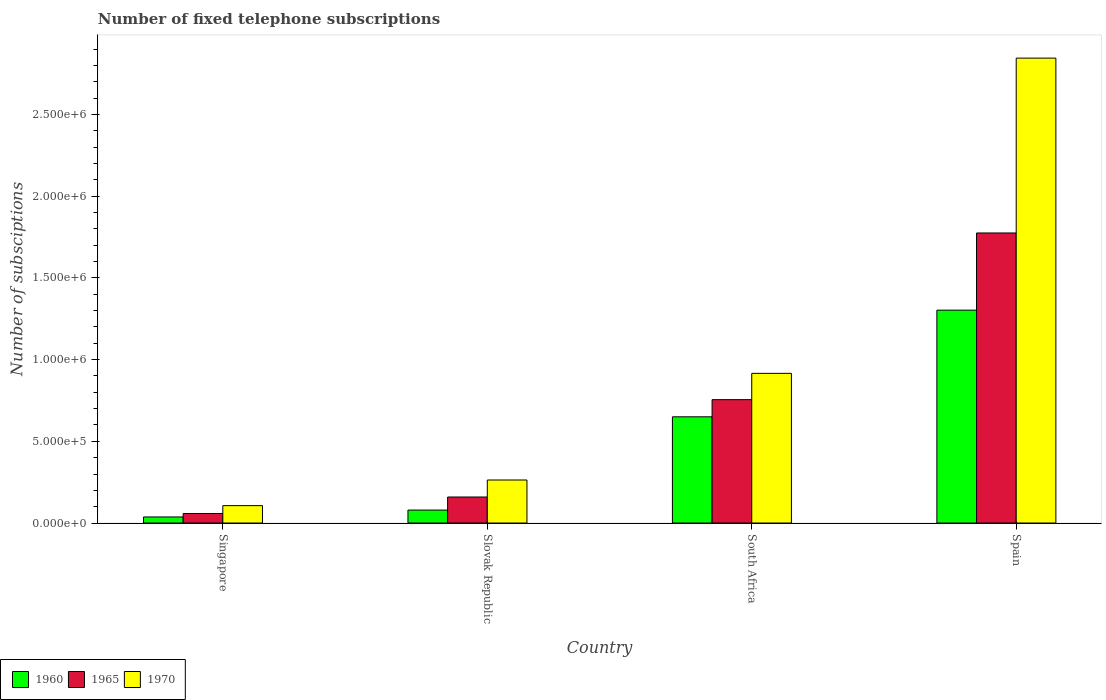How many bars are there on the 2nd tick from the left?
Provide a succinct answer. 3. What is the label of the 2nd group of bars from the left?
Offer a very short reply. Slovak Republic. In how many cases, is the number of bars for a given country not equal to the number of legend labels?
Keep it short and to the point. 0. What is the number of fixed telephone subscriptions in 1960 in Spain?
Your answer should be compact. 1.30e+06. Across all countries, what is the maximum number of fixed telephone subscriptions in 1970?
Give a very brief answer. 2.84e+06. Across all countries, what is the minimum number of fixed telephone subscriptions in 1960?
Ensure brevity in your answer.  3.71e+04. In which country was the number of fixed telephone subscriptions in 1970 maximum?
Offer a very short reply. Spain. In which country was the number of fixed telephone subscriptions in 1960 minimum?
Your answer should be compact. Singapore. What is the total number of fixed telephone subscriptions in 1960 in the graph?
Offer a very short reply. 2.07e+06. What is the difference between the number of fixed telephone subscriptions in 1960 in Singapore and that in Spain?
Your response must be concise. -1.27e+06. What is the difference between the number of fixed telephone subscriptions in 1960 in Singapore and the number of fixed telephone subscriptions in 1965 in Spain?
Keep it short and to the point. -1.74e+06. What is the average number of fixed telephone subscriptions in 1970 per country?
Offer a terse response. 1.03e+06. What is the difference between the number of fixed telephone subscriptions of/in 1965 and number of fixed telephone subscriptions of/in 1970 in South Africa?
Your answer should be compact. -1.61e+05. What is the ratio of the number of fixed telephone subscriptions in 1960 in Slovak Republic to that in Spain?
Make the answer very short. 0.06. Is the number of fixed telephone subscriptions in 1960 in Slovak Republic less than that in South Africa?
Ensure brevity in your answer.  Yes. Is the difference between the number of fixed telephone subscriptions in 1965 in Singapore and South Africa greater than the difference between the number of fixed telephone subscriptions in 1970 in Singapore and South Africa?
Your answer should be compact. Yes. What is the difference between the highest and the second highest number of fixed telephone subscriptions in 1965?
Your answer should be very brief. 1.02e+06. What is the difference between the highest and the lowest number of fixed telephone subscriptions in 1970?
Your answer should be compact. 2.74e+06. What does the 2nd bar from the left in South Africa represents?
Your answer should be very brief. 1965. What does the 2nd bar from the right in South Africa represents?
Ensure brevity in your answer.  1965. Is it the case that in every country, the sum of the number of fixed telephone subscriptions in 1970 and number of fixed telephone subscriptions in 1960 is greater than the number of fixed telephone subscriptions in 1965?
Provide a short and direct response. Yes. How many countries are there in the graph?
Offer a terse response. 4. What is the difference between two consecutive major ticks on the Y-axis?
Ensure brevity in your answer.  5.00e+05. Does the graph contain grids?
Keep it short and to the point. No. Where does the legend appear in the graph?
Keep it short and to the point. Bottom left. How many legend labels are there?
Provide a succinct answer. 3. What is the title of the graph?
Provide a succinct answer. Number of fixed telephone subscriptions. What is the label or title of the Y-axis?
Keep it short and to the point. Number of subsciptions. What is the Number of subsciptions of 1960 in Singapore?
Give a very brief answer. 3.71e+04. What is the Number of subsciptions in 1965 in Singapore?
Your answer should be compact. 5.84e+04. What is the Number of subsciptions in 1970 in Singapore?
Your answer should be very brief. 1.06e+05. What is the Number of subsciptions of 1960 in Slovak Republic?
Ensure brevity in your answer.  7.93e+04. What is the Number of subsciptions of 1965 in Slovak Republic?
Give a very brief answer. 1.59e+05. What is the Number of subsciptions in 1970 in Slovak Republic?
Your answer should be compact. 2.63e+05. What is the Number of subsciptions of 1960 in South Africa?
Provide a succinct answer. 6.50e+05. What is the Number of subsciptions of 1965 in South Africa?
Keep it short and to the point. 7.55e+05. What is the Number of subsciptions of 1970 in South Africa?
Provide a short and direct response. 9.16e+05. What is the Number of subsciptions in 1960 in Spain?
Give a very brief answer. 1.30e+06. What is the Number of subsciptions of 1965 in Spain?
Ensure brevity in your answer.  1.78e+06. What is the Number of subsciptions in 1970 in Spain?
Provide a succinct answer. 2.84e+06. Across all countries, what is the maximum Number of subsciptions of 1960?
Provide a short and direct response. 1.30e+06. Across all countries, what is the maximum Number of subsciptions of 1965?
Your answer should be compact. 1.78e+06. Across all countries, what is the maximum Number of subsciptions in 1970?
Keep it short and to the point. 2.84e+06. Across all countries, what is the minimum Number of subsciptions in 1960?
Offer a terse response. 3.71e+04. Across all countries, what is the minimum Number of subsciptions of 1965?
Give a very brief answer. 5.84e+04. Across all countries, what is the minimum Number of subsciptions in 1970?
Your answer should be very brief. 1.06e+05. What is the total Number of subsciptions of 1960 in the graph?
Make the answer very short. 2.07e+06. What is the total Number of subsciptions of 1965 in the graph?
Your answer should be compact. 2.75e+06. What is the total Number of subsciptions of 1970 in the graph?
Provide a succinct answer. 4.13e+06. What is the difference between the Number of subsciptions of 1960 in Singapore and that in Slovak Republic?
Provide a succinct answer. -4.22e+04. What is the difference between the Number of subsciptions of 1965 in Singapore and that in Slovak Republic?
Give a very brief answer. -1.01e+05. What is the difference between the Number of subsciptions of 1970 in Singapore and that in Slovak Republic?
Provide a succinct answer. -1.57e+05. What is the difference between the Number of subsciptions in 1960 in Singapore and that in South Africa?
Your answer should be compact. -6.13e+05. What is the difference between the Number of subsciptions in 1965 in Singapore and that in South Africa?
Give a very brief answer. -6.97e+05. What is the difference between the Number of subsciptions in 1970 in Singapore and that in South Africa?
Make the answer very short. -8.10e+05. What is the difference between the Number of subsciptions of 1960 in Singapore and that in Spain?
Your answer should be very brief. -1.27e+06. What is the difference between the Number of subsciptions of 1965 in Singapore and that in Spain?
Your answer should be very brief. -1.72e+06. What is the difference between the Number of subsciptions of 1970 in Singapore and that in Spain?
Provide a succinct answer. -2.74e+06. What is the difference between the Number of subsciptions of 1960 in Slovak Republic and that in South Africa?
Ensure brevity in your answer.  -5.71e+05. What is the difference between the Number of subsciptions in 1965 in Slovak Republic and that in South Africa?
Keep it short and to the point. -5.96e+05. What is the difference between the Number of subsciptions of 1970 in Slovak Republic and that in South Africa?
Provide a succinct answer. -6.53e+05. What is the difference between the Number of subsciptions of 1960 in Slovak Republic and that in Spain?
Offer a very short reply. -1.22e+06. What is the difference between the Number of subsciptions of 1965 in Slovak Republic and that in Spain?
Give a very brief answer. -1.62e+06. What is the difference between the Number of subsciptions of 1970 in Slovak Republic and that in Spain?
Provide a succinct answer. -2.58e+06. What is the difference between the Number of subsciptions in 1960 in South Africa and that in Spain?
Provide a succinct answer. -6.53e+05. What is the difference between the Number of subsciptions in 1965 in South Africa and that in Spain?
Keep it short and to the point. -1.02e+06. What is the difference between the Number of subsciptions in 1970 in South Africa and that in Spain?
Your answer should be compact. -1.93e+06. What is the difference between the Number of subsciptions of 1960 in Singapore and the Number of subsciptions of 1965 in Slovak Republic?
Your answer should be compact. -1.22e+05. What is the difference between the Number of subsciptions of 1960 in Singapore and the Number of subsciptions of 1970 in Slovak Republic?
Your answer should be very brief. -2.26e+05. What is the difference between the Number of subsciptions in 1965 in Singapore and the Number of subsciptions in 1970 in Slovak Republic?
Keep it short and to the point. -2.05e+05. What is the difference between the Number of subsciptions of 1960 in Singapore and the Number of subsciptions of 1965 in South Africa?
Offer a terse response. -7.18e+05. What is the difference between the Number of subsciptions of 1960 in Singapore and the Number of subsciptions of 1970 in South Africa?
Provide a short and direct response. -8.79e+05. What is the difference between the Number of subsciptions of 1965 in Singapore and the Number of subsciptions of 1970 in South Africa?
Offer a very short reply. -8.58e+05. What is the difference between the Number of subsciptions in 1960 in Singapore and the Number of subsciptions in 1965 in Spain?
Offer a terse response. -1.74e+06. What is the difference between the Number of subsciptions in 1960 in Singapore and the Number of subsciptions in 1970 in Spain?
Offer a terse response. -2.81e+06. What is the difference between the Number of subsciptions in 1965 in Singapore and the Number of subsciptions in 1970 in Spain?
Your answer should be very brief. -2.79e+06. What is the difference between the Number of subsciptions of 1960 in Slovak Republic and the Number of subsciptions of 1965 in South Africa?
Your answer should be compact. -6.76e+05. What is the difference between the Number of subsciptions of 1960 in Slovak Republic and the Number of subsciptions of 1970 in South Africa?
Provide a succinct answer. -8.37e+05. What is the difference between the Number of subsciptions in 1965 in Slovak Republic and the Number of subsciptions in 1970 in South Africa?
Ensure brevity in your answer.  -7.57e+05. What is the difference between the Number of subsciptions in 1960 in Slovak Republic and the Number of subsciptions in 1965 in Spain?
Your response must be concise. -1.70e+06. What is the difference between the Number of subsciptions of 1960 in Slovak Republic and the Number of subsciptions of 1970 in Spain?
Your response must be concise. -2.77e+06. What is the difference between the Number of subsciptions in 1965 in Slovak Republic and the Number of subsciptions in 1970 in Spain?
Your response must be concise. -2.69e+06. What is the difference between the Number of subsciptions of 1960 in South Africa and the Number of subsciptions of 1965 in Spain?
Keep it short and to the point. -1.12e+06. What is the difference between the Number of subsciptions of 1960 in South Africa and the Number of subsciptions of 1970 in Spain?
Your answer should be compact. -2.19e+06. What is the difference between the Number of subsciptions in 1965 in South Africa and the Number of subsciptions in 1970 in Spain?
Offer a very short reply. -2.09e+06. What is the average Number of subsciptions of 1960 per country?
Keep it short and to the point. 5.17e+05. What is the average Number of subsciptions of 1965 per country?
Offer a terse response. 6.87e+05. What is the average Number of subsciptions in 1970 per country?
Ensure brevity in your answer.  1.03e+06. What is the difference between the Number of subsciptions in 1960 and Number of subsciptions in 1965 in Singapore?
Your answer should be compact. -2.13e+04. What is the difference between the Number of subsciptions of 1960 and Number of subsciptions of 1970 in Singapore?
Provide a succinct answer. -6.93e+04. What is the difference between the Number of subsciptions in 1965 and Number of subsciptions in 1970 in Singapore?
Provide a short and direct response. -4.81e+04. What is the difference between the Number of subsciptions in 1960 and Number of subsciptions in 1965 in Slovak Republic?
Offer a very short reply. -7.99e+04. What is the difference between the Number of subsciptions in 1960 and Number of subsciptions in 1970 in Slovak Republic?
Your response must be concise. -1.84e+05. What is the difference between the Number of subsciptions in 1965 and Number of subsciptions in 1970 in Slovak Republic?
Provide a succinct answer. -1.04e+05. What is the difference between the Number of subsciptions of 1960 and Number of subsciptions of 1965 in South Africa?
Your answer should be compact. -1.05e+05. What is the difference between the Number of subsciptions in 1960 and Number of subsciptions in 1970 in South Africa?
Your response must be concise. -2.66e+05. What is the difference between the Number of subsciptions in 1965 and Number of subsciptions in 1970 in South Africa?
Your answer should be very brief. -1.61e+05. What is the difference between the Number of subsciptions in 1960 and Number of subsciptions in 1965 in Spain?
Keep it short and to the point. -4.72e+05. What is the difference between the Number of subsciptions in 1960 and Number of subsciptions in 1970 in Spain?
Give a very brief answer. -1.54e+06. What is the difference between the Number of subsciptions in 1965 and Number of subsciptions in 1970 in Spain?
Offer a very short reply. -1.07e+06. What is the ratio of the Number of subsciptions in 1960 in Singapore to that in Slovak Republic?
Your response must be concise. 0.47. What is the ratio of the Number of subsciptions in 1965 in Singapore to that in Slovak Republic?
Provide a succinct answer. 0.37. What is the ratio of the Number of subsciptions in 1970 in Singapore to that in Slovak Republic?
Ensure brevity in your answer.  0.4. What is the ratio of the Number of subsciptions in 1960 in Singapore to that in South Africa?
Make the answer very short. 0.06. What is the ratio of the Number of subsciptions in 1965 in Singapore to that in South Africa?
Your answer should be compact. 0.08. What is the ratio of the Number of subsciptions of 1970 in Singapore to that in South Africa?
Provide a succinct answer. 0.12. What is the ratio of the Number of subsciptions of 1960 in Singapore to that in Spain?
Offer a terse response. 0.03. What is the ratio of the Number of subsciptions in 1965 in Singapore to that in Spain?
Give a very brief answer. 0.03. What is the ratio of the Number of subsciptions in 1970 in Singapore to that in Spain?
Keep it short and to the point. 0.04. What is the ratio of the Number of subsciptions of 1960 in Slovak Republic to that in South Africa?
Provide a succinct answer. 0.12. What is the ratio of the Number of subsciptions of 1965 in Slovak Republic to that in South Africa?
Make the answer very short. 0.21. What is the ratio of the Number of subsciptions of 1970 in Slovak Republic to that in South Africa?
Provide a succinct answer. 0.29. What is the ratio of the Number of subsciptions in 1960 in Slovak Republic to that in Spain?
Ensure brevity in your answer.  0.06. What is the ratio of the Number of subsciptions in 1965 in Slovak Republic to that in Spain?
Give a very brief answer. 0.09. What is the ratio of the Number of subsciptions in 1970 in Slovak Republic to that in Spain?
Provide a short and direct response. 0.09. What is the ratio of the Number of subsciptions in 1960 in South Africa to that in Spain?
Provide a succinct answer. 0.5. What is the ratio of the Number of subsciptions in 1965 in South Africa to that in Spain?
Your answer should be compact. 0.43. What is the ratio of the Number of subsciptions of 1970 in South Africa to that in Spain?
Ensure brevity in your answer.  0.32. What is the difference between the highest and the second highest Number of subsciptions in 1960?
Ensure brevity in your answer.  6.53e+05. What is the difference between the highest and the second highest Number of subsciptions of 1965?
Your response must be concise. 1.02e+06. What is the difference between the highest and the second highest Number of subsciptions in 1970?
Provide a short and direct response. 1.93e+06. What is the difference between the highest and the lowest Number of subsciptions of 1960?
Ensure brevity in your answer.  1.27e+06. What is the difference between the highest and the lowest Number of subsciptions in 1965?
Give a very brief answer. 1.72e+06. What is the difference between the highest and the lowest Number of subsciptions of 1970?
Your answer should be very brief. 2.74e+06. 